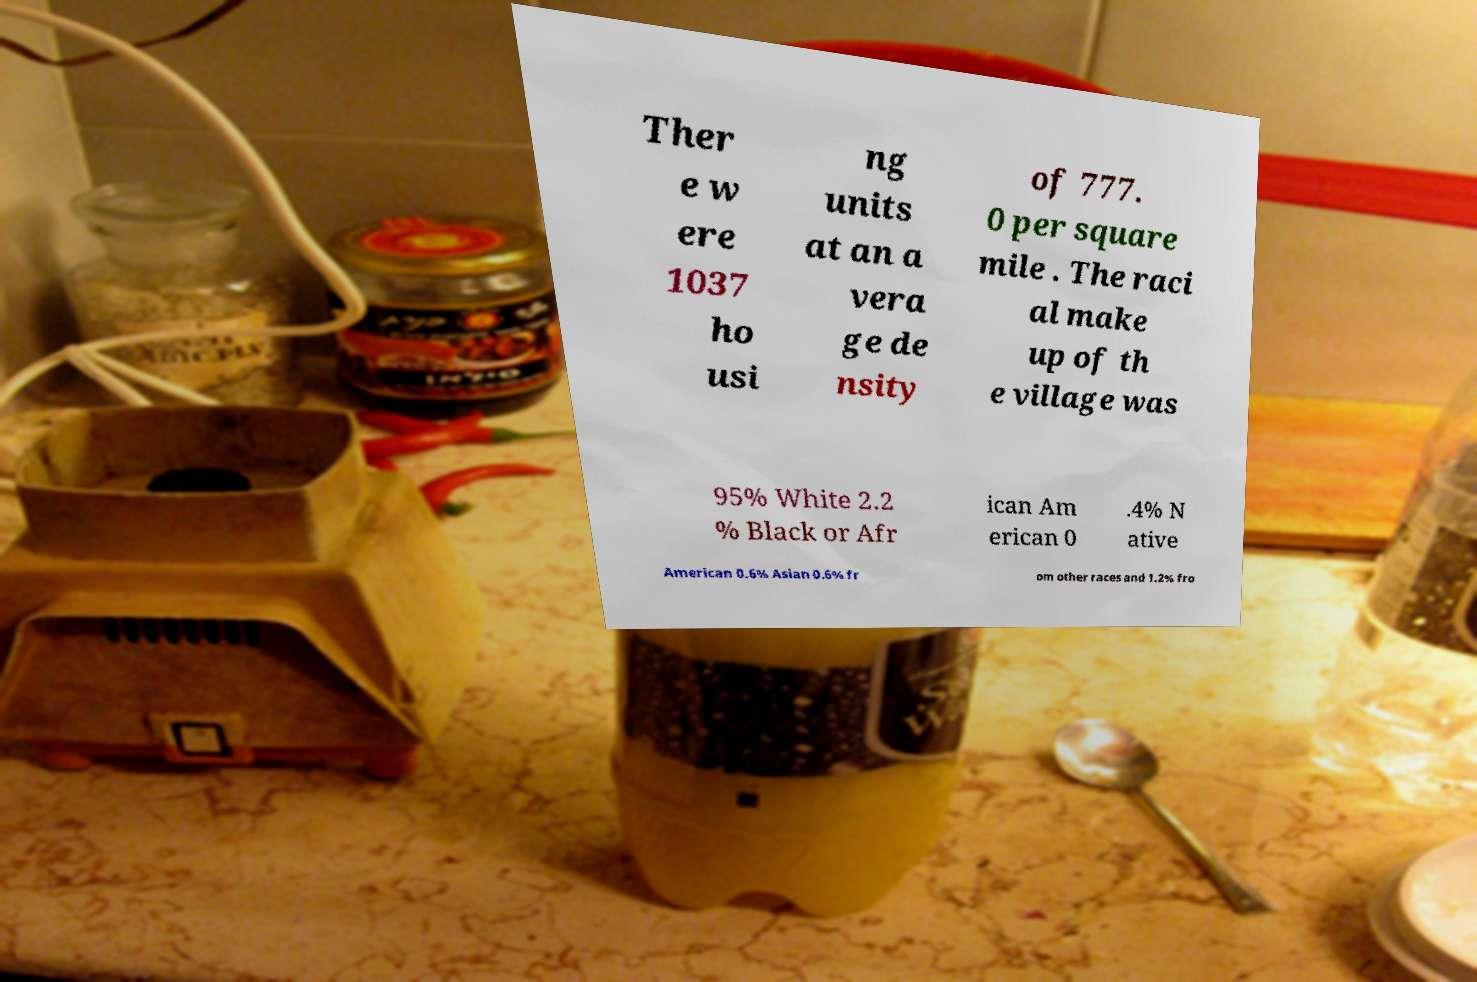There's text embedded in this image that I need extracted. Can you transcribe it verbatim? Ther e w ere 1037 ho usi ng units at an a vera ge de nsity of 777. 0 per square mile . The raci al make up of th e village was 95% White 2.2 % Black or Afr ican Am erican 0 .4% N ative American 0.6% Asian 0.6% fr om other races and 1.2% fro 